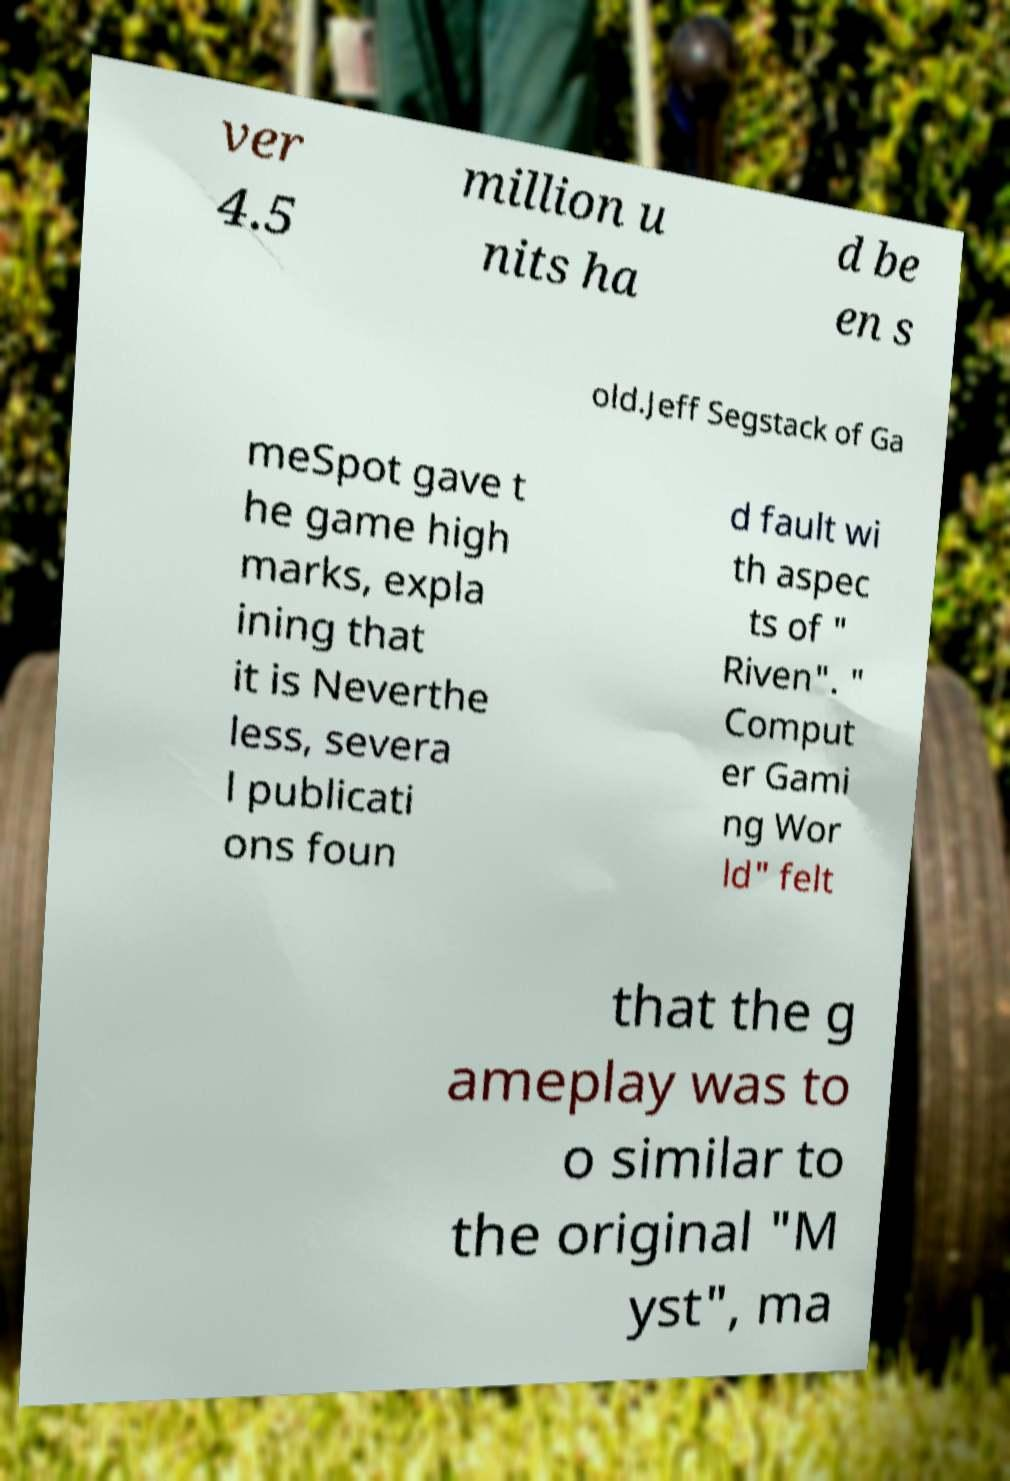Please identify and transcribe the text found in this image. ver 4.5 million u nits ha d be en s old.Jeff Segstack of Ga meSpot gave t he game high marks, expla ining that it is Neverthe less, severa l publicati ons foun d fault wi th aspec ts of " Riven". " Comput er Gami ng Wor ld" felt that the g ameplay was to o similar to the original "M yst", ma 